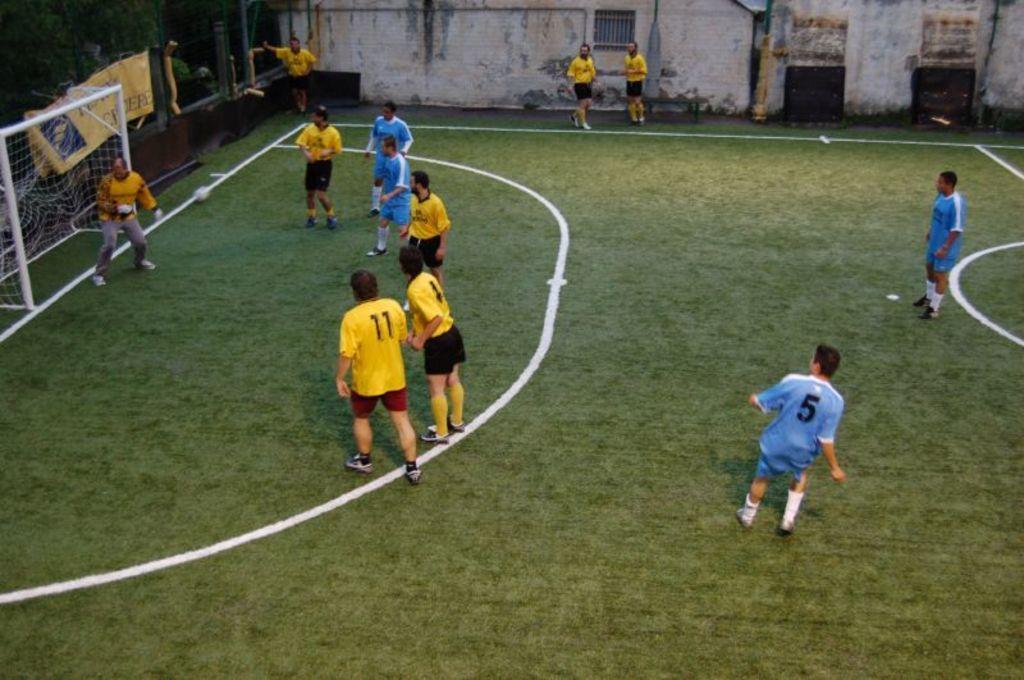How would you summarize this image in a sentence or two? In the center of the image, we can see people and in the background, there is a frame with net and a banner and some poles, a bench and there is a wall and there are trees and we can see some objects. At the bottom, there is ground. 